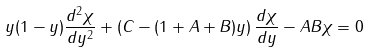Convert formula to latex. <formula><loc_0><loc_0><loc_500><loc_500>y ( 1 - y ) \frac { d ^ { 2 } \chi } { d y ^ { 2 } } + \left ( C - ( 1 + A + B ) y \right ) \frac { d \chi } { d y } - A B \chi = 0</formula> 